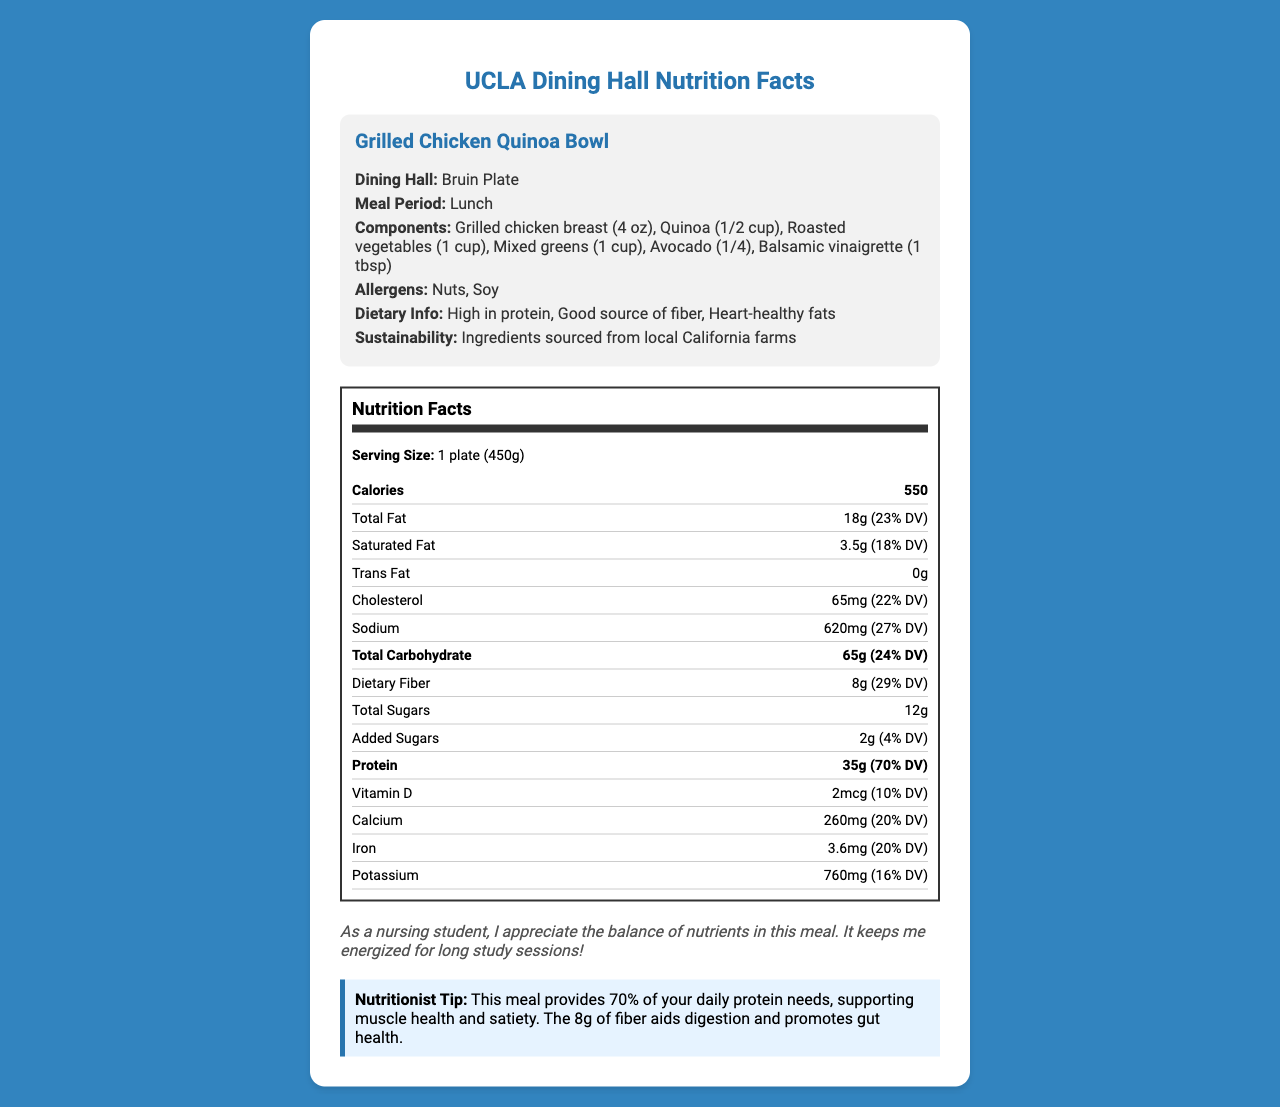How many grams of protein are in the Grilled Chicken Quinoa Bowl? The document states that the protein content is 35 grams.
Answer: 35 grams What is the serving size mentioned for the Grilled Chicken Quinoa Bowl? The document lists the serving size as 1 plate (450g).
Answer: 1 plate (450g) Which dining hall offers the Grilled Chicken Quinoa Bowl? The document indicates that this meal is offered at Bruin Plate.
Answer: Bruin Plate What percentage of the daily value of dietary fiber does this meal provide? According to the document, the dietary fiber content is 8 grams, which is 29% of the daily value.
Answer: 29% Is the Grilled Chicken Quinoa Bowl high in protein? The document categorizes the meal as "High in protein".
Answer: Yes What are the main components of the Grilled Chicken Quinoa Bowl? A. Grilled chicken breast, Brown rice, and Mixed greens B. Grilled chicken breast, Quinoa, and Roasted vegetables C. Grilled chicken breast, Kale, and Sweet potato The document lists the components as Grilled chicken breast, Quinoa, Roasted vegetables, Mixed greens, Avocado, and Balsamic vinaigrette.
Answer: B How many grams of total carbohydrate does the Grilled Chicken Quinoa Bowl contain? The document specifies that the meal has 65 grams of total carbohydrate.
Answer: 65 grams Does the meal contain any allergens? The meal contains nuts and soy, as stated in the document.
Answer: Yes Which of the following nutrients are found in larger amounts compared to the daily value: Total Fat, Protein, or Dietary Fiber? A. Total Fat B. Protein C. Dietary Fiber The daily values for Total Fat, Protein, and Dietary Fiber are 23%, 70%, and 29% respectively. Protein has the highest daily value percentage.
Answer: B What specific nutrition information is highlighted by the Nutritionist Tip at the end of the document? The Nutritionist Tip mentions that the meal provides 70% of daily protein needs and discusses the benefits of fiber.
Answer: Daily protein needs and fiber benefits What sustainable practice is mentioned regarding the meal ingredients? The document mentions that ingredients are sourced from local California farms.
Answer: Ingredients sourced from local California farms Summarize the nutritional benefits of the Grilled Chicken Quinoa Bowl as presented in the document. The summary includes various key points: meal name, components, calorie count, high protein and fiber content, sustainability practices, and its suitability for long study sessions mentioned by a student review.
Answer: The Grilled Chicken Quinoa Bowl is a balanced meal high in protein and fiber, offering a variety of meal components including grilled chicken, quinoa, vegetables, and mixed greens. With 550 calories per serving, it provides substantial protein (70% DV) to support muscle health and digestion-friendly fiber (29% DV). The meal is also noted for its sustainability, being sourced from local California farms. It contains nuts and soy as allergens. The meal is particularly beneficial for sustaining energy levels, making it suitable for long study sessions. What are the potential allergens in the Grilled Chicken Quinoa Bowl? The document lists nuts and soy as allergens in the meal.
Answer: Nuts, Soy Why might a student appreciate this meal? According to a student review in the document, the balance of nutrients keeps them energized for long study sessions.
Answer: It keeps them energized for long study sessions. What is the sodium content in milligrams for the Grilled Chicken Quinoa Bowl? The document specifies that the sodium content is 620 mg.
Answer: 620 mg How much calcium does the meal provide in milligrams, and what percentage of the daily value is this? The document states that the meal contains 260 mg of calcium, which is 20% of the daily value.
Answer: 260 mg, 20% DV How many added sugars are there in the Grilled Chicken Quinoa Bowl? The document indicates that the meal contains 2 grams of added sugars.
Answer: 2 grams What is the amount of Vitamin D present in the meal? The document mentions that the meal contains 2 micrograms of Vitamin D.
Answer: 2 mcg Does the document provide information on the specific farms where ingredients are sourced? The document states that ingredients are sourced from local California farms but does not specify the names or locations of these farms.
Answer: Not enough information 